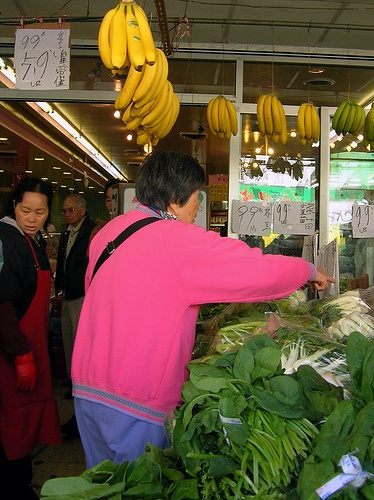Describe the objects in this image and their specific colors. I can see people in darkgreen, salmon, black, and blue tones, people in darkgreen, black, maroon, brown, and salmon tones, people in darkgreen, black, maroon, olive, and gray tones, banana in darkgreen, gold, orange, and olive tones, and banana in darkgreen, orange, olive, and maroon tones in this image. 